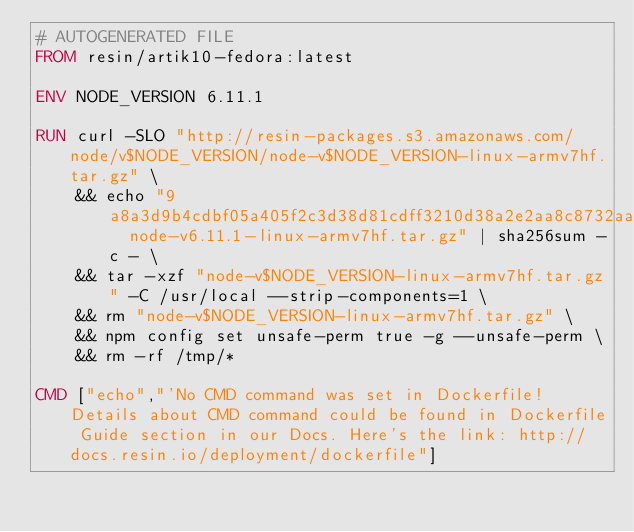<code> <loc_0><loc_0><loc_500><loc_500><_Dockerfile_># AUTOGENERATED FILE
FROM resin/artik10-fedora:latest

ENV NODE_VERSION 6.11.1

RUN curl -SLO "http://resin-packages.s3.amazonaws.com/node/v$NODE_VERSION/node-v$NODE_VERSION-linux-armv7hf.tar.gz" \
	&& echo "9a8a3d9b4cdbf05a405f2c3d38d81cdff3210d38a2e2aa8c8732aa69534b19e7  node-v6.11.1-linux-armv7hf.tar.gz" | sha256sum -c - \
	&& tar -xzf "node-v$NODE_VERSION-linux-armv7hf.tar.gz" -C /usr/local --strip-components=1 \
	&& rm "node-v$NODE_VERSION-linux-armv7hf.tar.gz" \
	&& npm config set unsafe-perm true -g --unsafe-perm \
	&& rm -rf /tmp/*

CMD ["echo","'No CMD command was set in Dockerfile! Details about CMD command could be found in Dockerfile Guide section in our Docs. Here's the link: http://docs.resin.io/deployment/dockerfile"]
</code> 